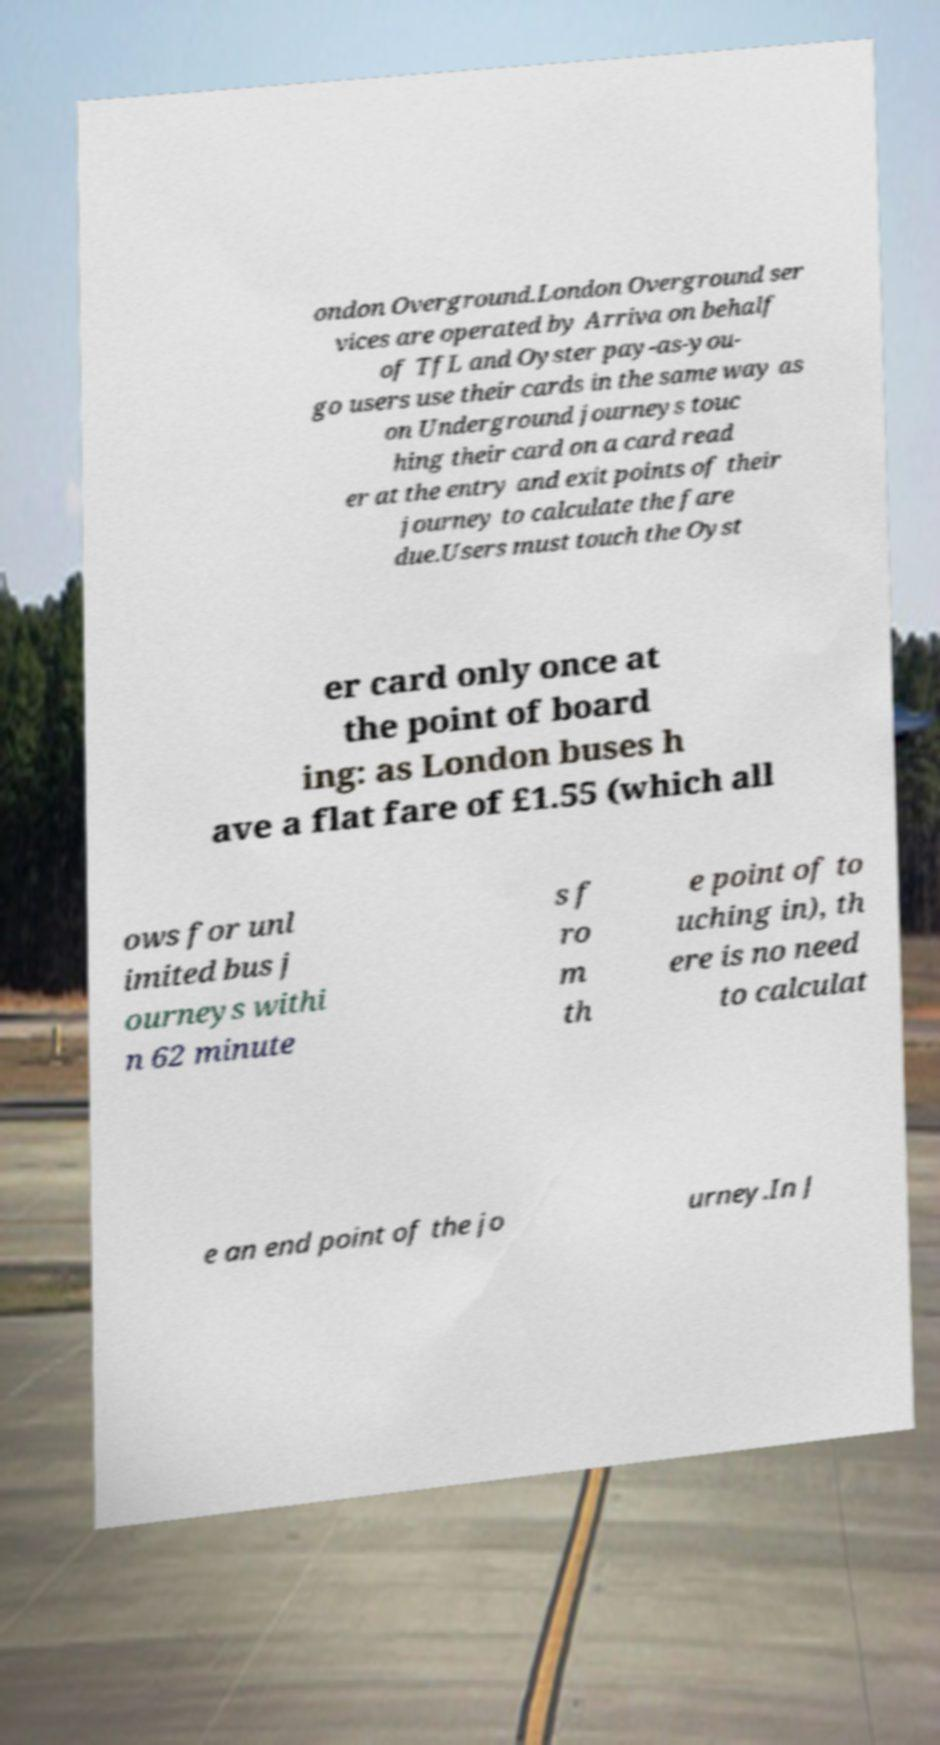Please read and relay the text visible in this image. What does it say? ondon Overground.London Overground ser vices are operated by Arriva on behalf of TfL and Oyster pay-as-you- go users use their cards in the same way as on Underground journeys touc hing their card on a card read er at the entry and exit points of their journey to calculate the fare due.Users must touch the Oyst er card only once at the point of board ing: as London buses h ave a flat fare of £1.55 (which all ows for unl imited bus j ourneys withi n 62 minute s f ro m th e point of to uching in), th ere is no need to calculat e an end point of the jo urney.In J 